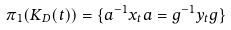<formula> <loc_0><loc_0><loc_500><loc_500>\pi _ { 1 } ( K _ { D } ( t ) ) = \{ a ^ { - 1 } x _ { t } a = g ^ { - 1 } y _ { t } g \}</formula> 